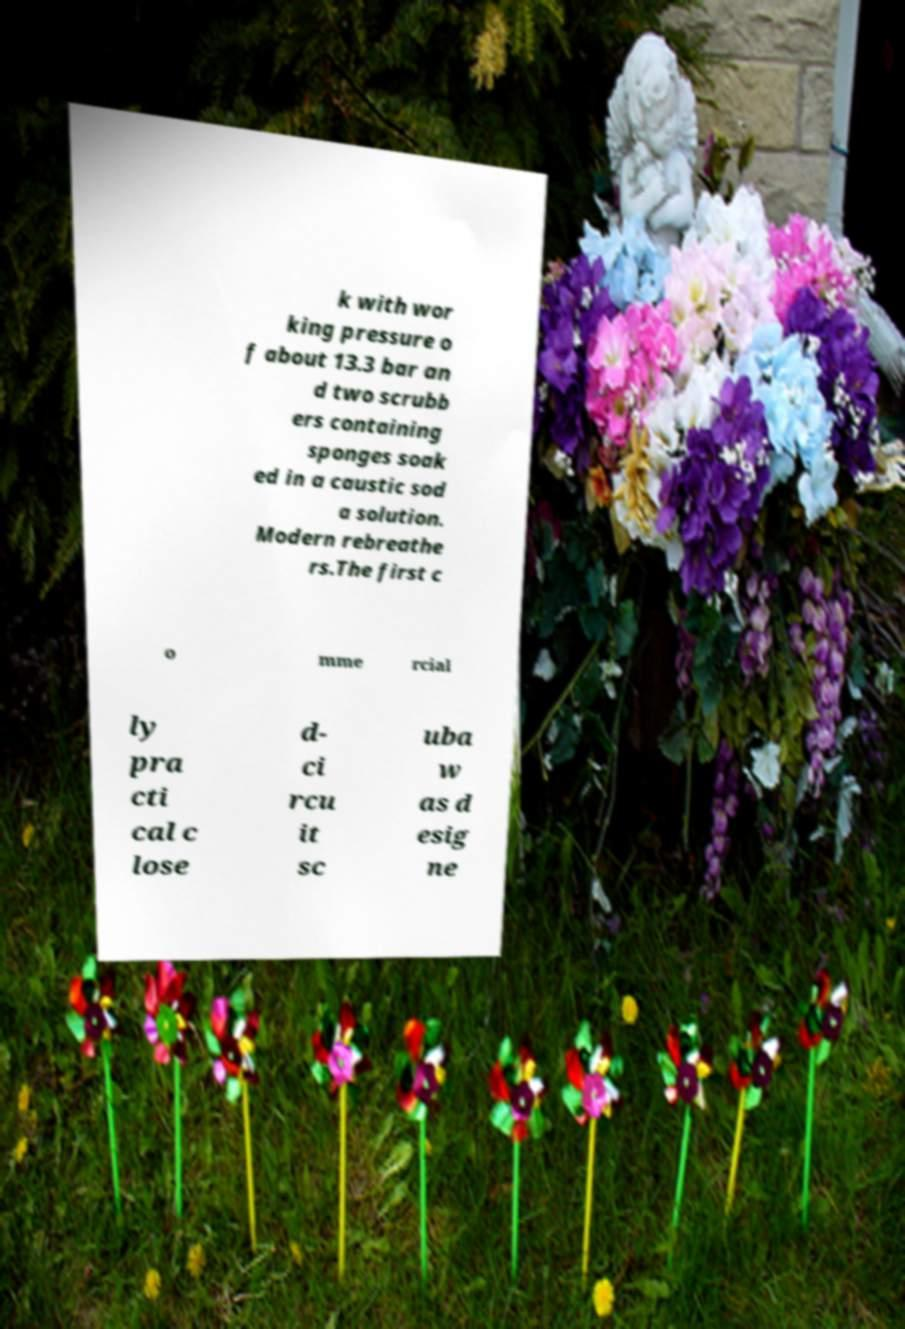Could you extract and type out the text from this image? k with wor king pressure o f about 13.3 bar an d two scrubb ers containing sponges soak ed in a caustic sod a solution. Modern rebreathe rs.The first c o mme rcial ly pra cti cal c lose d- ci rcu it sc uba w as d esig ne 